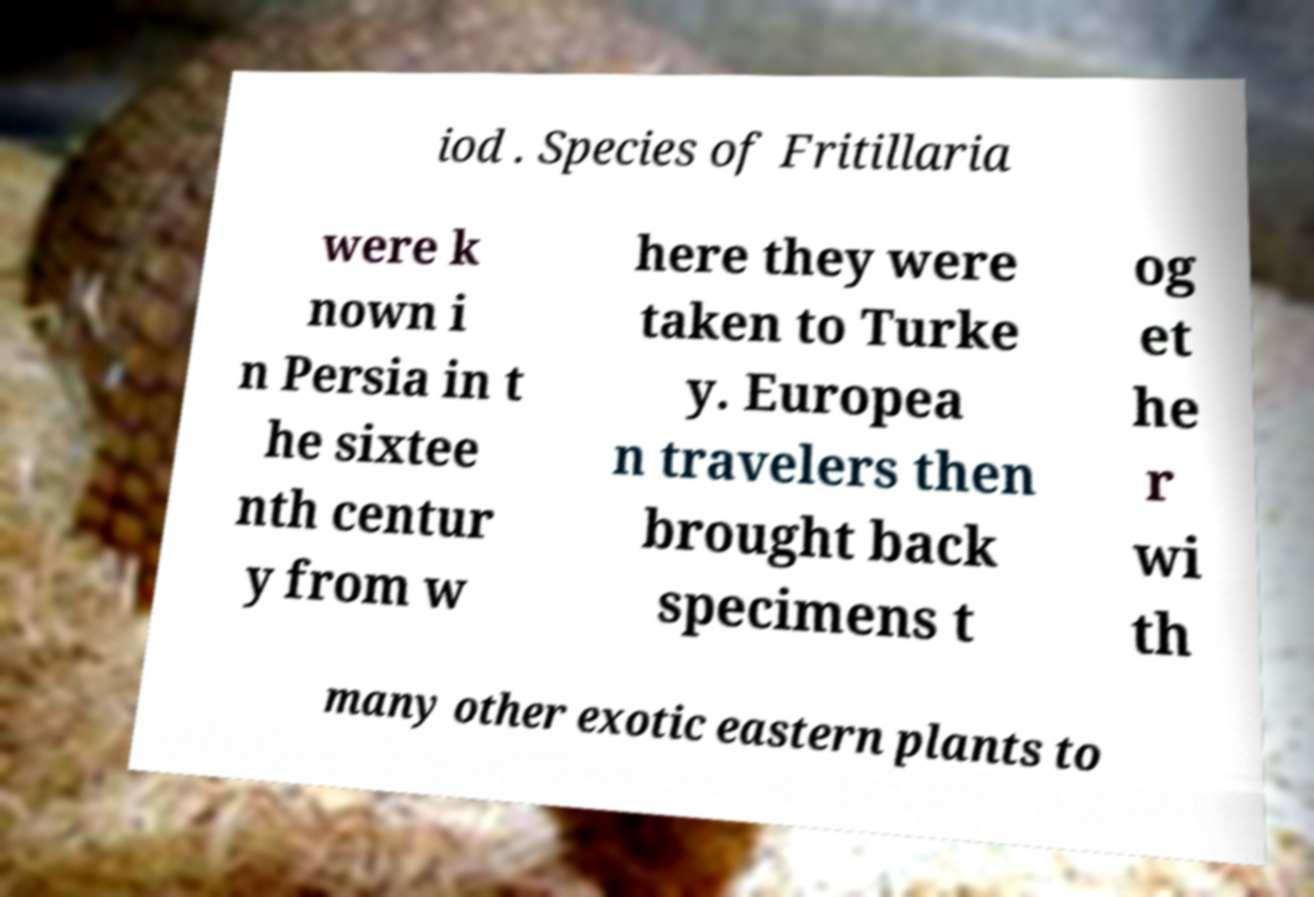Please read and relay the text visible in this image. What does it say? iod . Species of Fritillaria were k nown i n Persia in t he sixtee nth centur y from w here they were taken to Turke y. Europea n travelers then brought back specimens t og et he r wi th many other exotic eastern plants to 